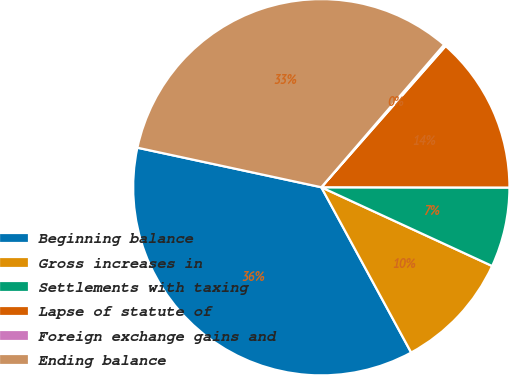<chart> <loc_0><loc_0><loc_500><loc_500><pie_chart><fcel>Beginning balance<fcel>Gross increases in<fcel>Settlements with taxing<fcel>Lapse of statute of<fcel>Foreign exchange gains and<fcel>Ending balance<nl><fcel>36.3%<fcel>10.2%<fcel>6.85%<fcel>13.54%<fcel>0.17%<fcel>32.95%<nl></chart> 